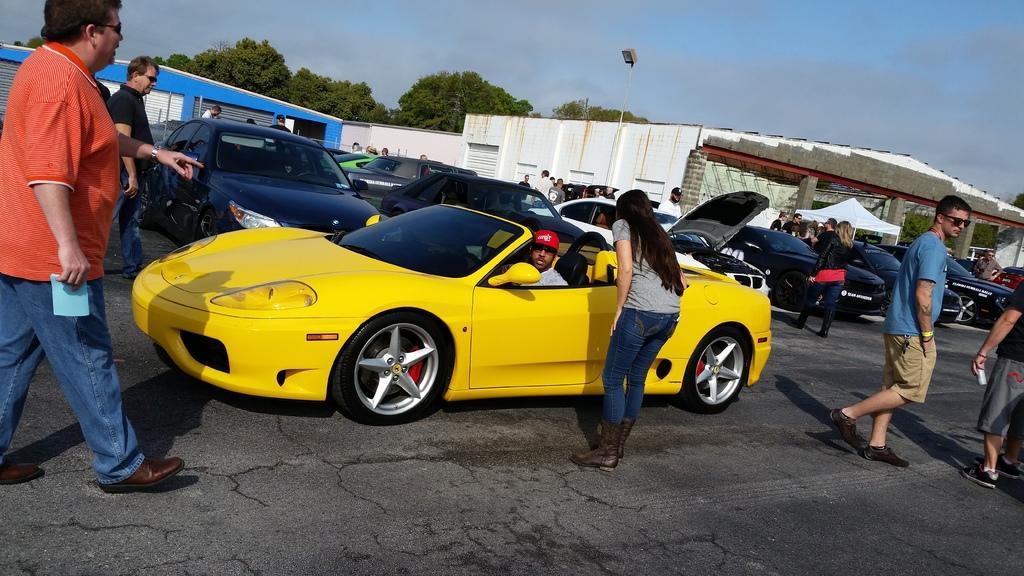Describe this image in one or two sentences. In this image I can see number of people are standing. I can also see number of cars and here in this car I can see a man is sitting and I can see he is wearing red colour cap. In the background I can see few buildings, trees, clouds, sky and a light. Here I can see few people are wearing shades. 